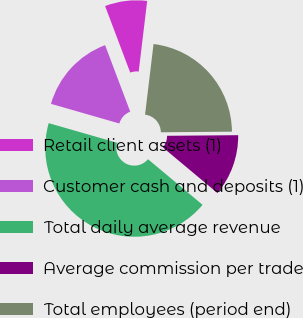<chart> <loc_0><loc_0><loc_500><loc_500><pie_chart><fcel>Retail client assets (1)<fcel>Customer cash and deposits (1)<fcel>Total daily average revenue<fcel>Average commission per trade<fcel>Total employees (period end)<nl><fcel>7.65%<fcel>14.8%<fcel>43.37%<fcel>11.22%<fcel>22.96%<nl></chart> 